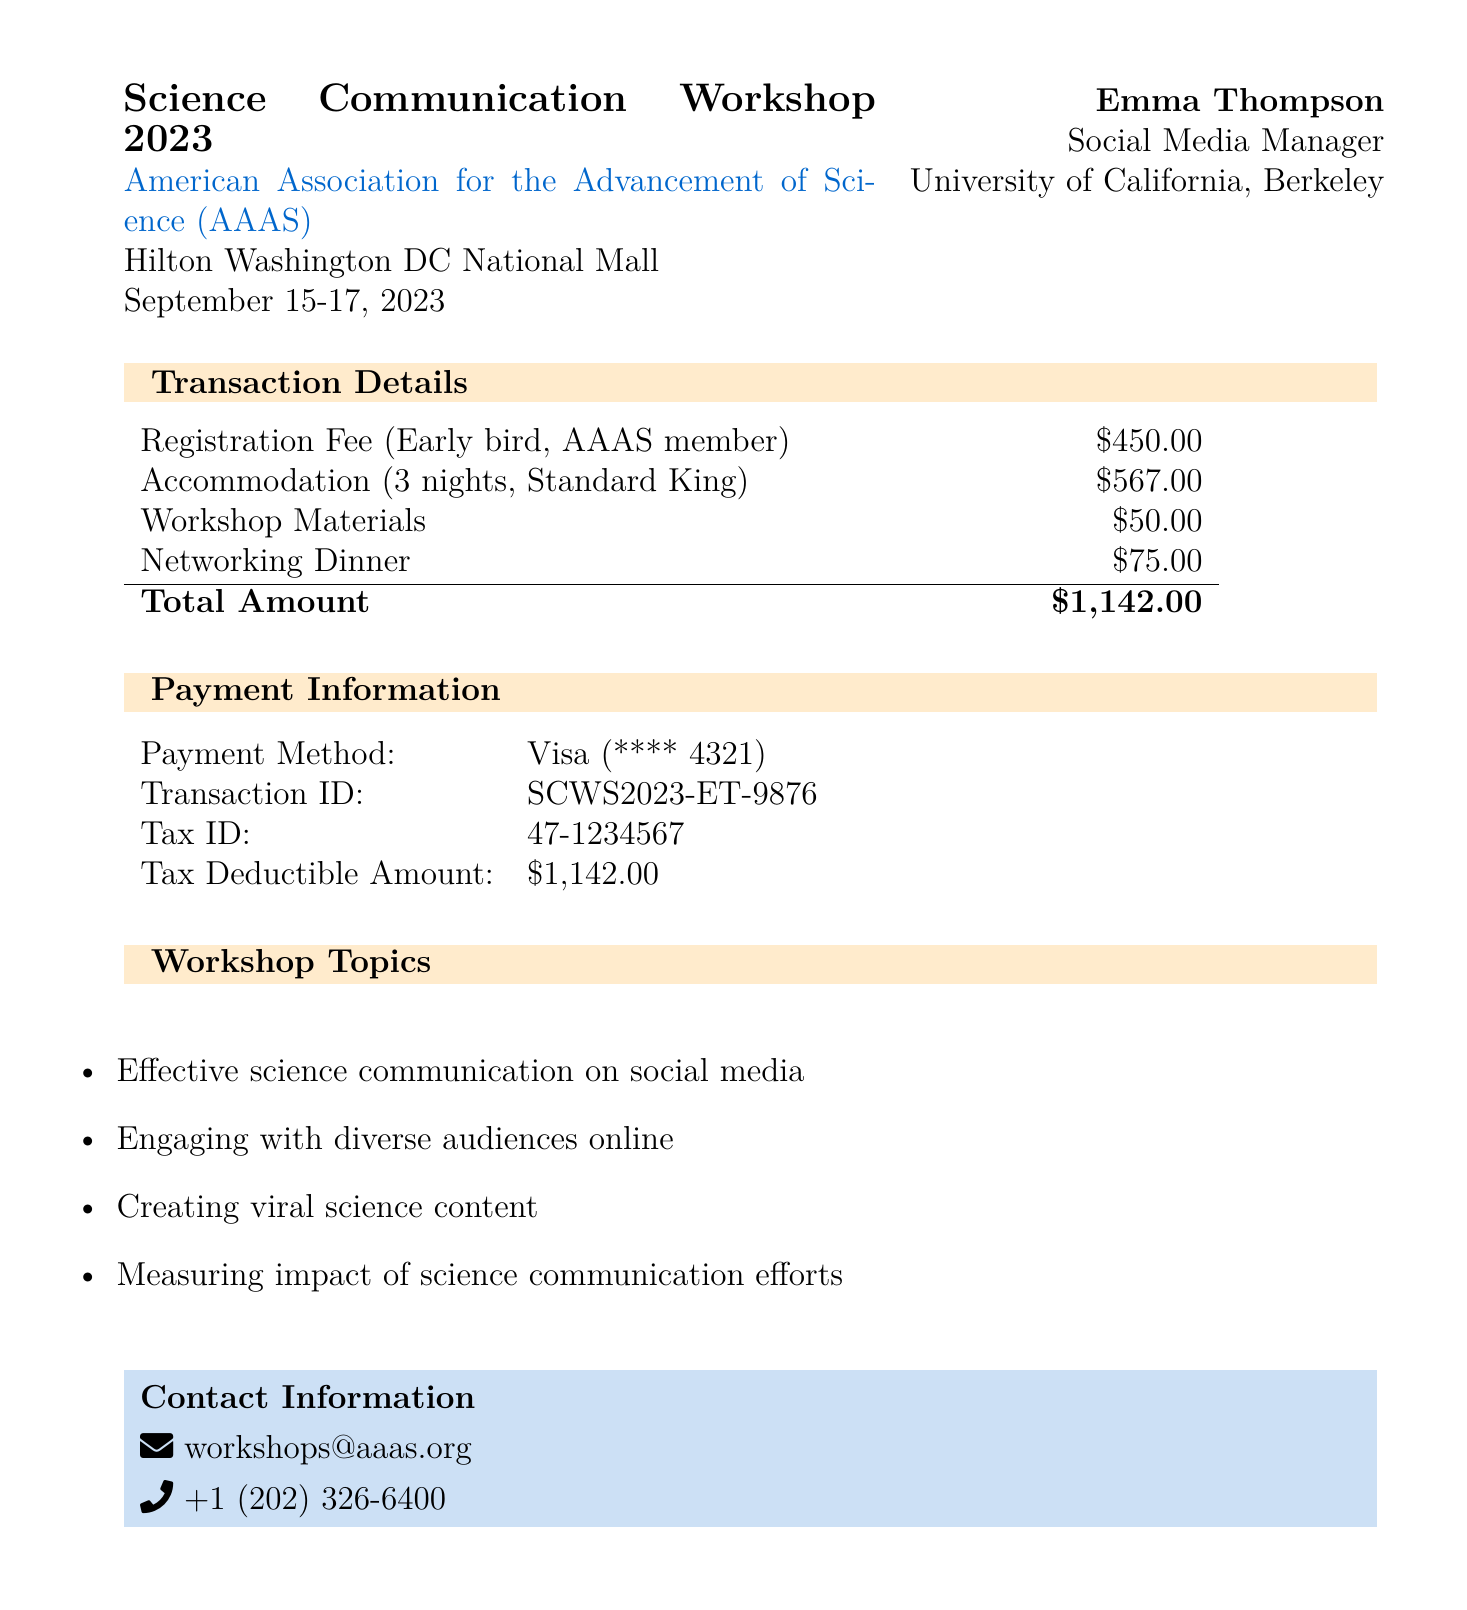What is the name of the workshop? The workshop is referred to as the "Science Communication Workshop 2023" in the document.
Answer: Science Communication Workshop 2023 Who organized the workshop? The document explicitly mentions that the workshop is organized by the "American Association for the Advancement of Science (AAAS)."
Answer: American Association for the Advancement of Science (AAAS) What is the total amount paid for the registration and accommodation? The total amount is presented as the sum of all expenses, which equals $1142.00.
Answer: $1,142.00 How many nights was the accommodation booked for? The document states that accommodation was booked for "3 nights."
Answer: 3 nights What was the rate per night for the accommodation? The accommodation section indicates the rate was "$189" per night.
Answer: $189 What payment method was used for the registration fee? The document lists the payment method as "Credit Card (Visa)."
Answer: Credit Card (Visa) List one topic covered in the workshop. The workshop topics section includes various topics, such as "Effective science communication on social media."
Answer: Effective science communication on social media What is the receipt number? The receipt number is stated as "SCWS2023-1234" in the document.
Answer: SCWS2023-1234 How much was spent on additional expenses? The document shows additional expenses adding up to $125 (workshop materials and networking dinner).
Answer: $125 